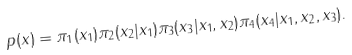<formula> <loc_0><loc_0><loc_500><loc_500>p ( x ) = \pi _ { 1 } ( x _ { 1 } ) \pi _ { 2 } ( x _ { 2 } | x _ { 1 } ) \pi _ { 3 } ( x _ { 3 } | x _ { 1 } , x _ { 2 } ) \pi _ { 4 } ( x _ { 4 } | x _ { 1 } , x _ { 2 } , x _ { 3 } ) .</formula> 